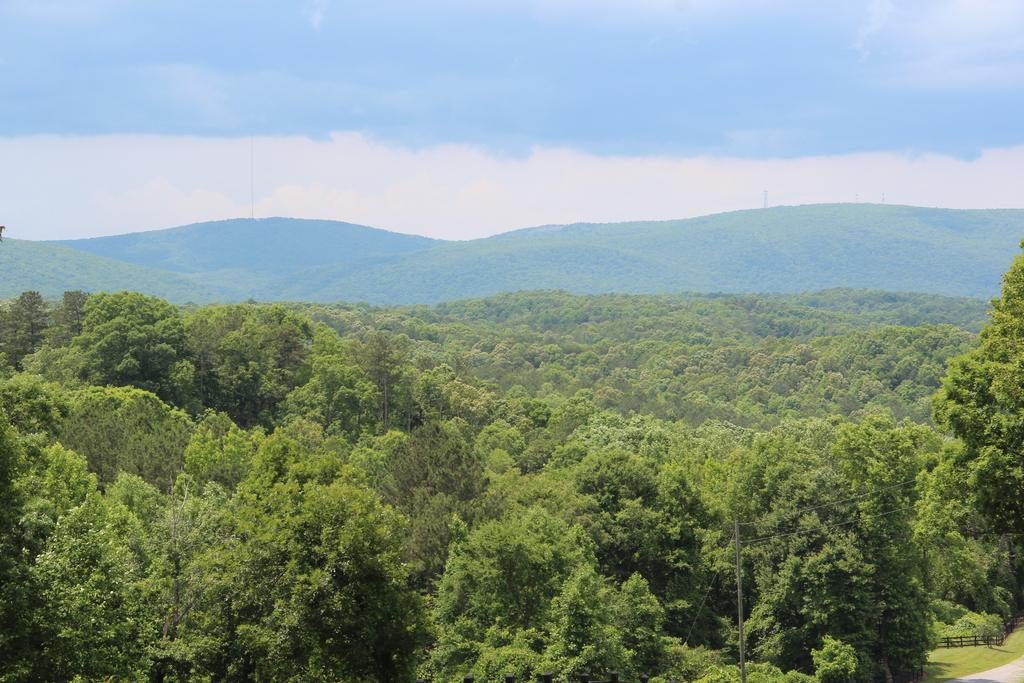What type of vegetation can be seen in the image? There are many trees in the image. What type of geographical feature is visible in the background of the image? There is a mountain in the background of the image. What is visible in the sky at the top of the image? There are clouds visible in the sky at the top of the image. How many corks are on the ground in the image? There are no corks present in the image. Are the sisters playing near the trees in the image? There is no mention of sisters in the image, so we cannot answer this question. 